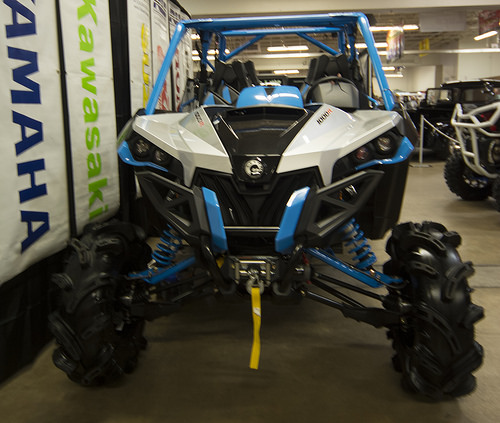<image>
Is there a ribbon under the under? Yes. The ribbon is positioned underneath the under, with the under above it in the vertical space. 